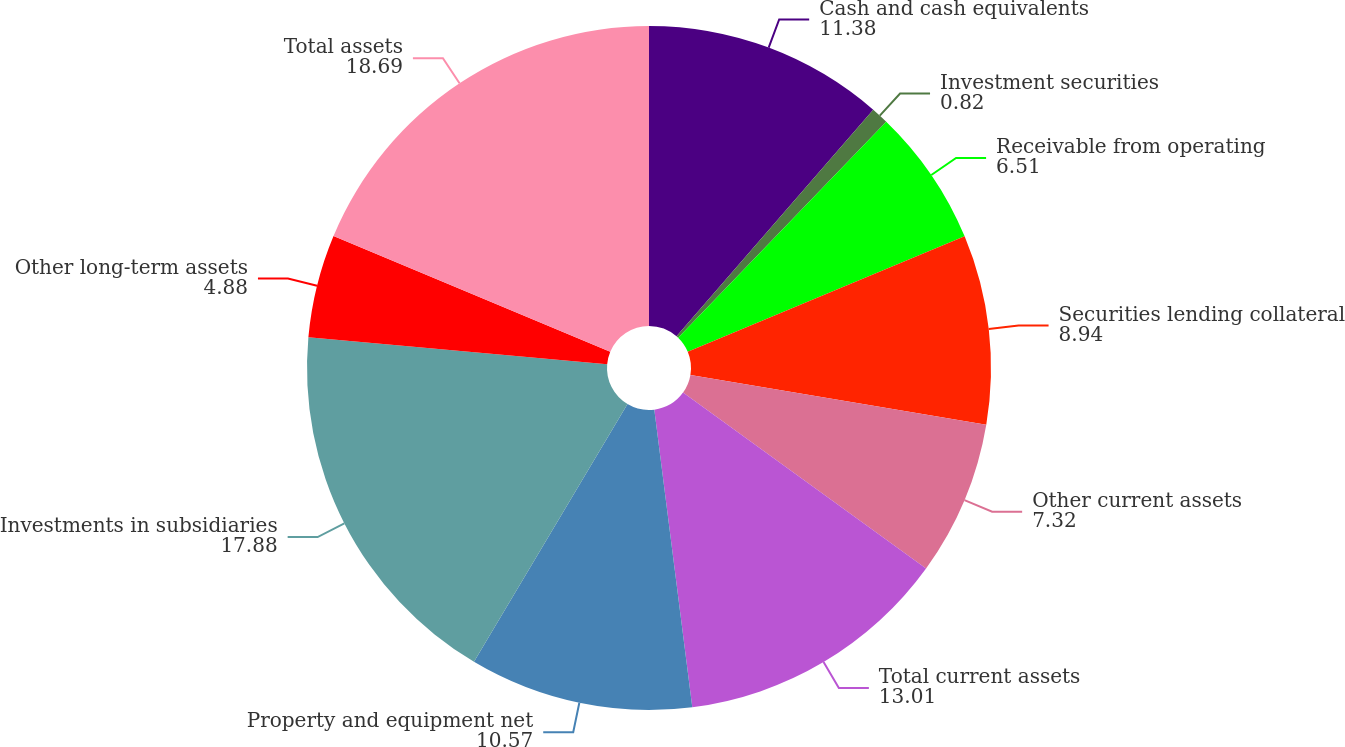Convert chart to OTSL. <chart><loc_0><loc_0><loc_500><loc_500><pie_chart><fcel>Cash and cash equivalents<fcel>Investment securities<fcel>Receivable from operating<fcel>Securities lending collateral<fcel>Other current assets<fcel>Total current assets<fcel>Property and equipment net<fcel>Investments in subsidiaries<fcel>Other long-term assets<fcel>Total assets<nl><fcel>11.38%<fcel>0.82%<fcel>6.51%<fcel>8.94%<fcel>7.32%<fcel>13.01%<fcel>10.57%<fcel>17.88%<fcel>4.88%<fcel>18.69%<nl></chart> 